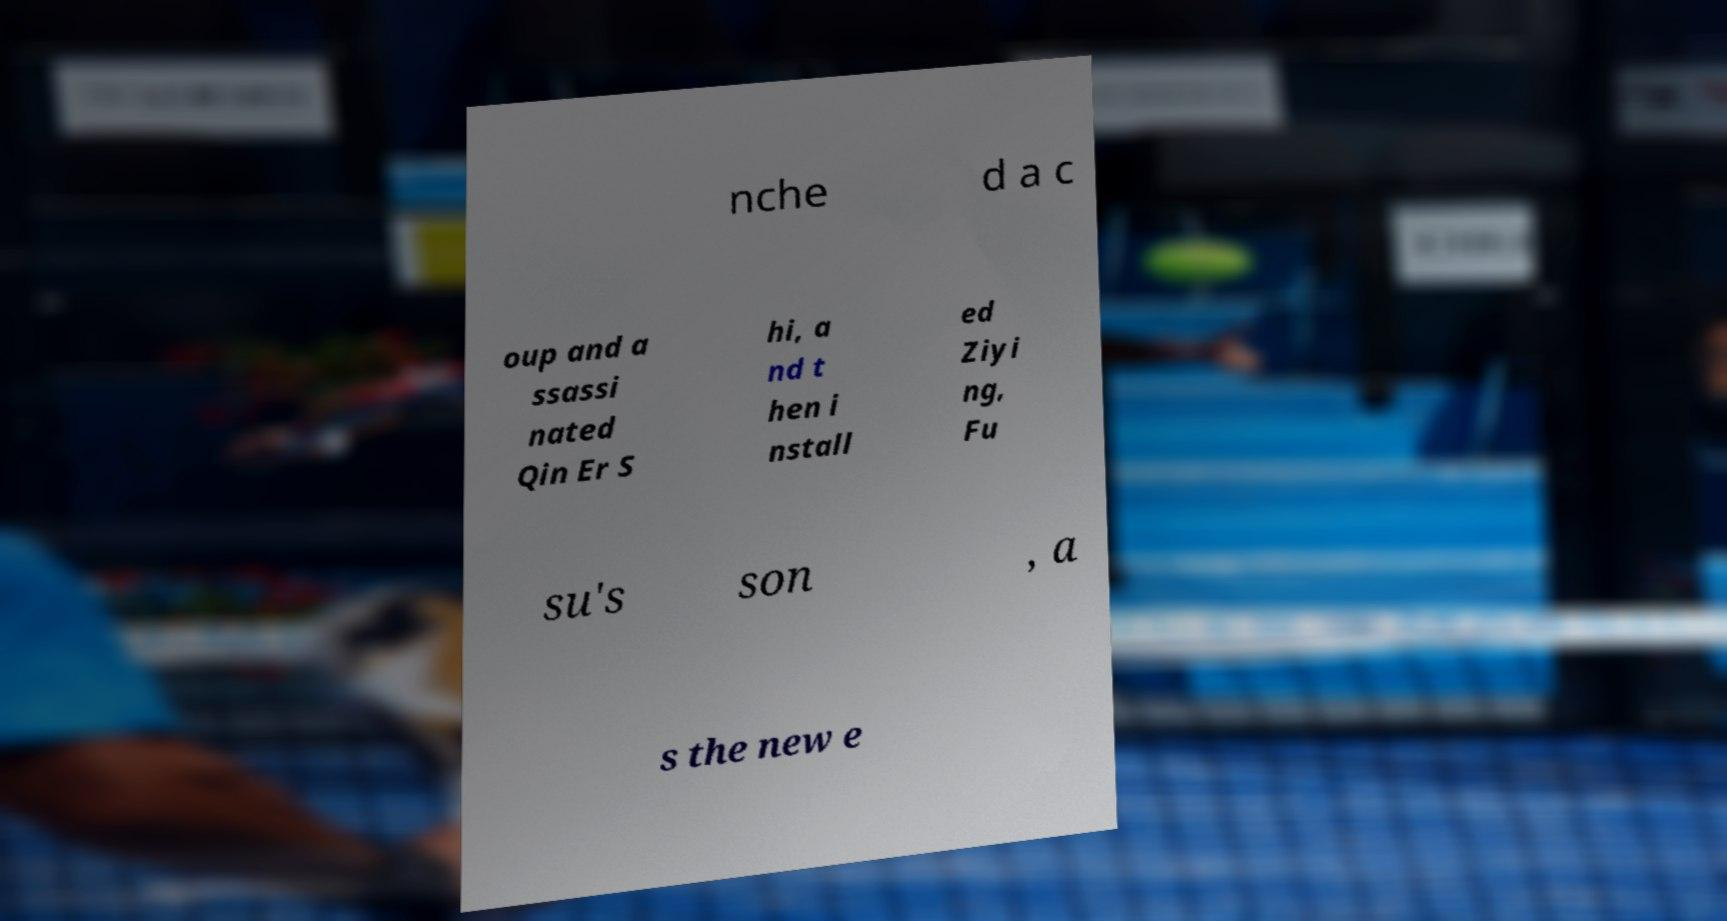Please identify and transcribe the text found in this image. nche d a c oup and a ssassi nated Qin Er S hi, a nd t hen i nstall ed Ziyi ng, Fu su's son , a s the new e 